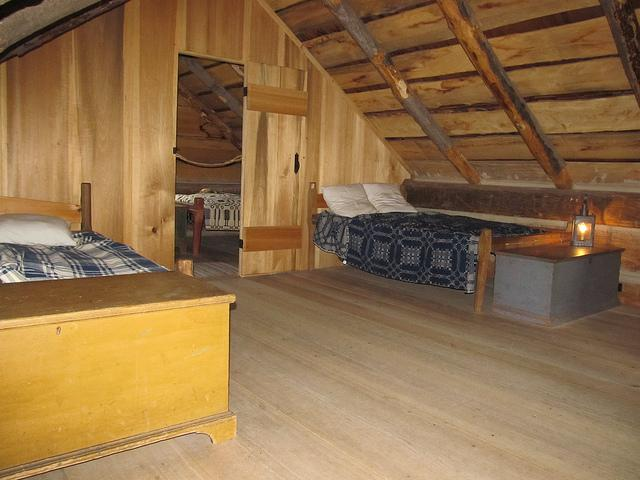What color of light is emanated by the lantern on the top of the footlocker?

Choices:
A) orange
B) black
C) white
D) pink orange 